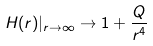<formula> <loc_0><loc_0><loc_500><loc_500>H ( r ) | _ { r \rightarrow \infty } \rightarrow 1 + \frac { Q } { r ^ { 4 } }</formula> 